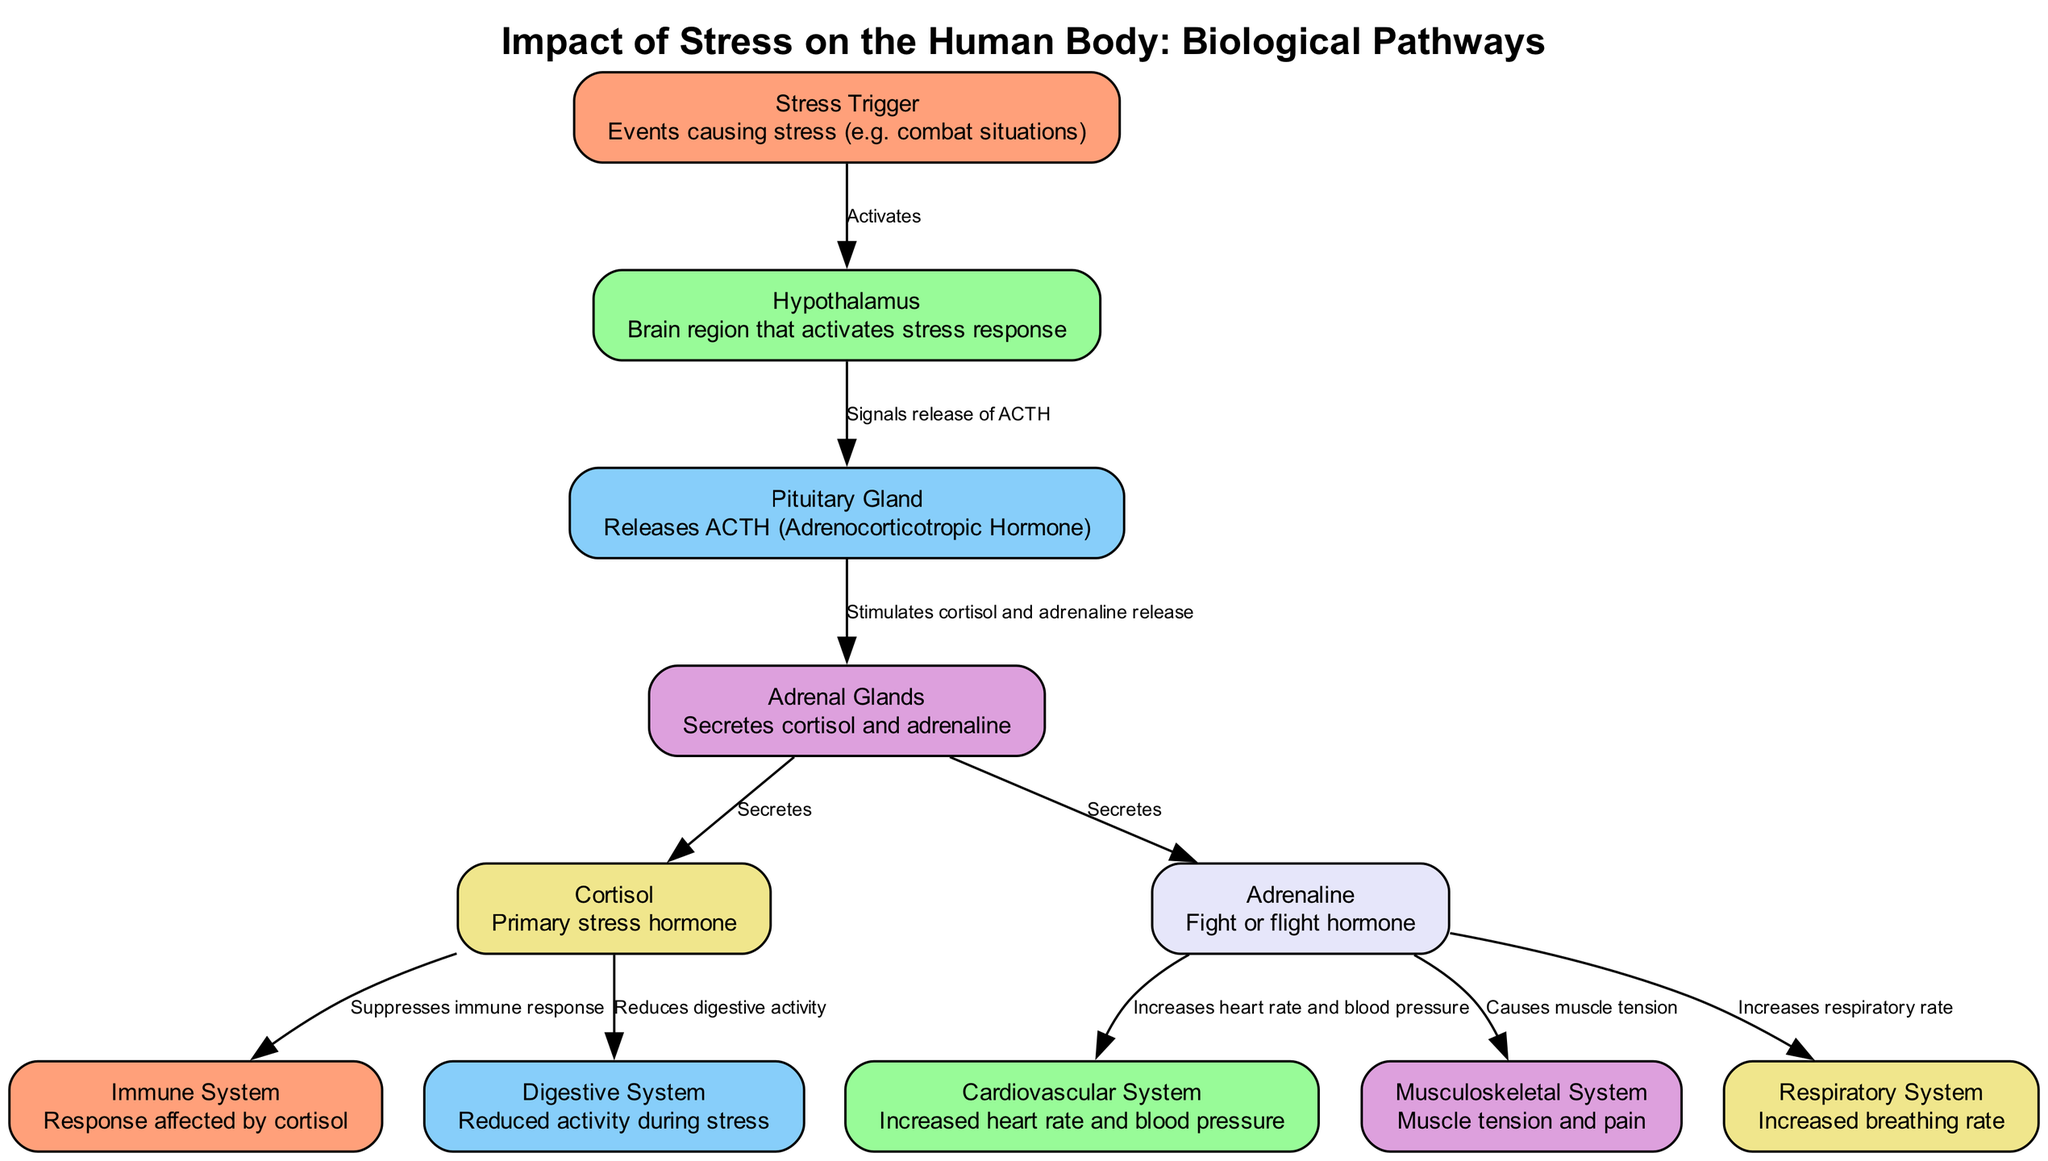What is the first node in the diagram? The first node in the diagram is labeled "Stress Trigger," which indicates the initial events causing stress. This can be found at the top of the diagram as it is where the flow begins.
Answer: Stress Trigger How many nodes are present in the diagram? Counting each of the individual nodes from the diagram, we find a total of 11 distinct nodes representing various components related to stress impact on the human body.
Answer: 11 What hormone is primarily released by the adrenal glands? The adrenal glands in the diagram release two hormones, cortisol and adrenaline, but cortisol is specifically labeled as the primary stress hormone.
Answer: Cortisol Which system is most directly affected by cortisol? According to the diagram, cortisol has a direct influence on the immune system, as it is indicated that cortisol suppresses the immune response.
Answer: Immune System What is the effect of adrenaline on the cardiovascular system? The connection between adrenaline and the cardiovascular system shows that adrenaline increases heart rate and blood pressure. This links the hormone directly to its physiological impact.
Answer: Increases heart rate and blood pressure What signals the release of ACTH? The arrow leads from the "Hypothalamus" node to the "Pituitary Gland," indicating that the hypothalamus signals the release of ACTH (Adrenocorticotropic Hormone) as part of the stress response.
Answer: Hypothalamus How does stress affect the digestive system according to the diagram? The diagram illustrates that during stress, cortisol reduces digestive activity, highlighting the response of the digestive system to stress-induced hormone activity.
Answer: Reduces digestive activity What physiological change occurs in the musculoskeletal system due to adrenaline? The diagram connects adrenaline to the musculoskeletal system, specifying that it causes muscle tension during stress situations. This is a response meant to prepare the body for action.
Answer: Causes muscle tension 